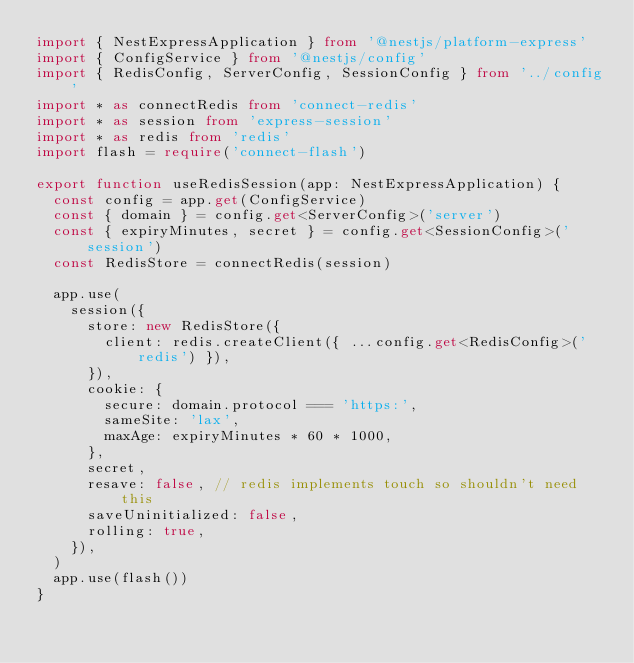Convert code to text. <code><loc_0><loc_0><loc_500><loc_500><_TypeScript_>import { NestExpressApplication } from '@nestjs/platform-express'
import { ConfigService } from '@nestjs/config'
import { RedisConfig, ServerConfig, SessionConfig } from '../config'
import * as connectRedis from 'connect-redis'
import * as session from 'express-session'
import * as redis from 'redis'
import flash = require('connect-flash')

export function useRedisSession(app: NestExpressApplication) {
  const config = app.get(ConfigService)
  const { domain } = config.get<ServerConfig>('server')
  const { expiryMinutes, secret } = config.get<SessionConfig>('session')
  const RedisStore = connectRedis(session)

  app.use(
    session({
      store: new RedisStore({
        client: redis.createClient({ ...config.get<RedisConfig>('redis') }),
      }),
      cookie: {
        secure: domain.protocol === 'https:',
        sameSite: 'lax',
        maxAge: expiryMinutes * 60 * 1000,
      },
      secret,
      resave: false, // redis implements touch so shouldn't need this
      saveUninitialized: false,
      rolling: true,
    }),
  )
  app.use(flash())
}
</code> 